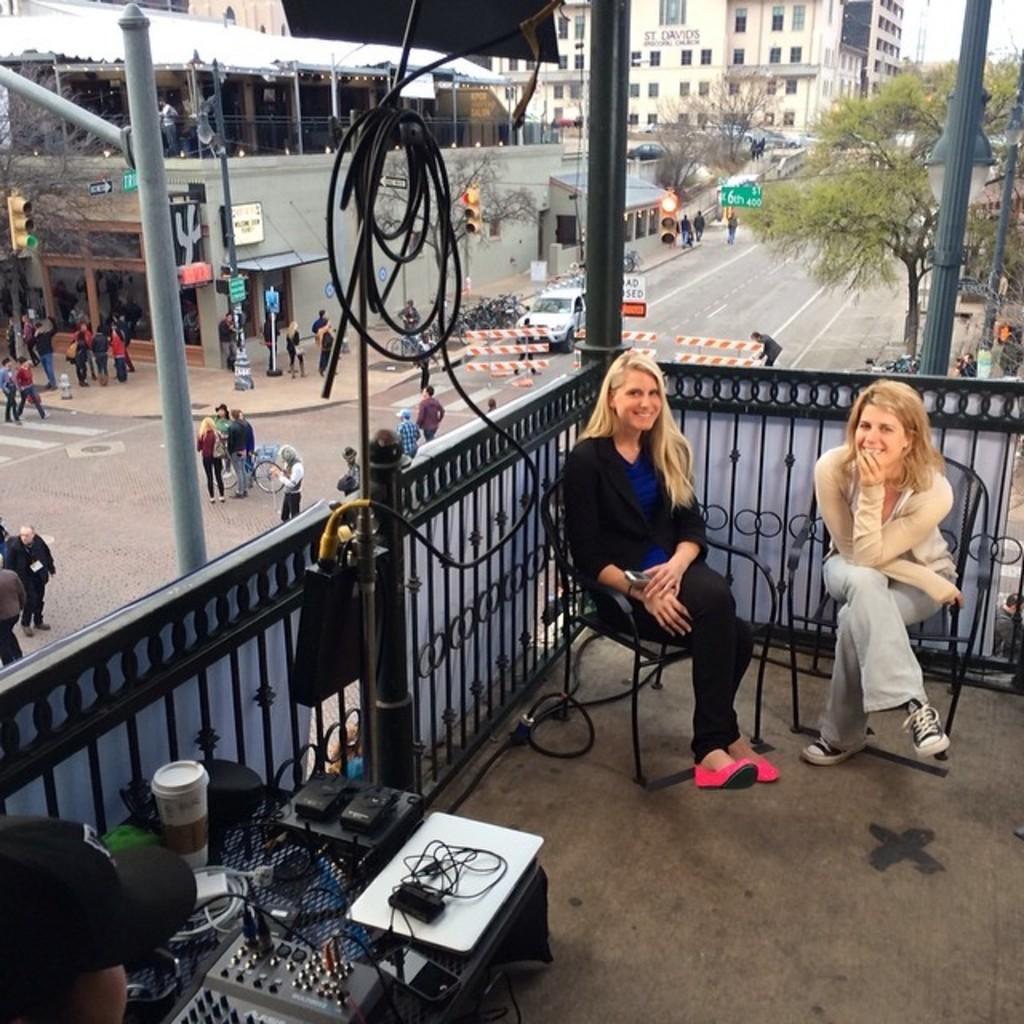How would you summarize this image in a sentence or two? In this image we can see the balcony of a building, there are two women sitting on their chairs and there are a few objects placed on the table, there is a person, there are a few people standing and walking on the road, there are buildings, trees, street lights, signals and in the background there is the sky. 